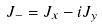<formula> <loc_0><loc_0><loc_500><loc_500>J _ { - } = J _ { x } - i J _ { y }</formula> 